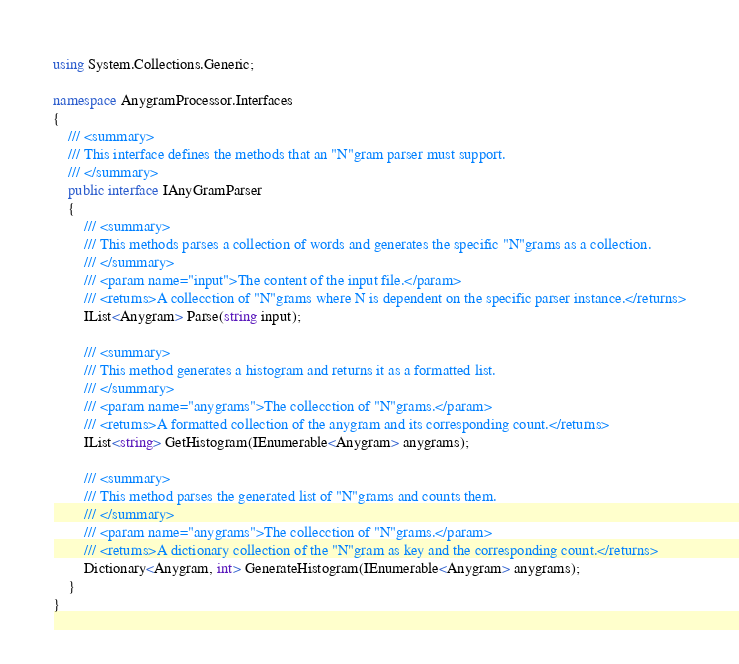Convert code to text. <code><loc_0><loc_0><loc_500><loc_500><_C#_>using System.Collections.Generic;

namespace AnygramProcessor.Interfaces
{
    /// <summary>
    /// This interface defines the methods that an "N"gram parser must support.
    /// </summary>
    public interface IAnyGramParser
    {
        /// <summary>
        /// This methods parses a collection of words and generates the specific "N"grams as a collection.
        /// </summary>
        /// <param name="input">The content of the input file.</param>
        /// <returns>A collecction of "N"grams where N is dependent on the specific parser instance.</returns>
        IList<Anygram> Parse(string input);

        /// <summary>
        /// This method generates a histogram and returns it as a formatted list.
        /// </summary>
        /// <param name="anygrams">The collecction of "N"grams.</param>
        /// <returns>A formatted collection of the anygram and its corresponding count.</returns>
        IList<string> GetHistogram(IEnumerable<Anygram> anygrams);

        /// <summary>
        /// This method parses the generated list of "N"grams and counts them.
        /// </summary>
        /// <param name="anygrams">The collecction of "N"grams.</param>
        /// <returns>A dictionary collection of the "N"gram as key and the corresponding count.</returns>
        Dictionary<Anygram, int> GenerateHistogram(IEnumerable<Anygram> anygrams);
    }
}</code> 